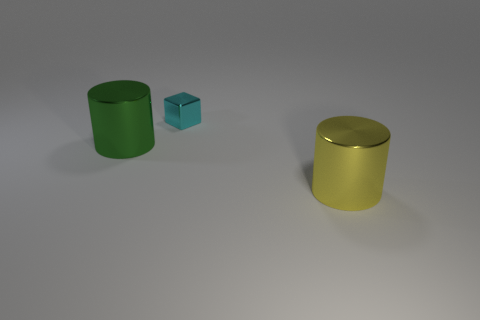Add 3 cyan metallic cubes. How many objects exist? 6 Subtract all blocks. How many objects are left? 2 Subtract all large yellow cylinders. Subtract all small metal cubes. How many objects are left? 1 Add 1 large green metallic cylinders. How many large green metallic cylinders are left? 2 Add 2 small red things. How many small red things exist? 2 Subtract 1 cyan blocks. How many objects are left? 2 Subtract 1 blocks. How many blocks are left? 0 Subtract all red cubes. Subtract all purple balls. How many cubes are left? 1 